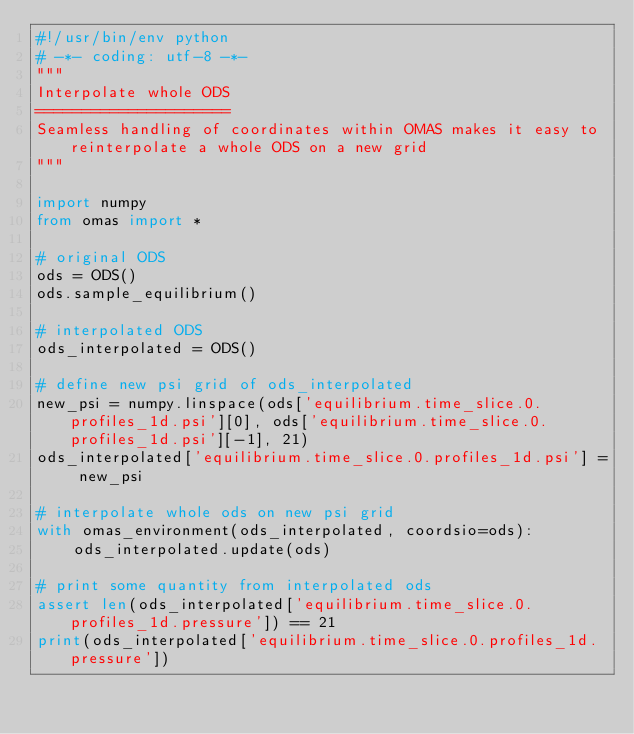Convert code to text. <code><loc_0><loc_0><loc_500><loc_500><_Python_>#!/usr/bin/env python
# -*- coding: utf-8 -*-
"""
Interpolate whole ODS
=====================
Seamless handling of coordinates within OMAS makes it easy to reinterpolate a whole ODS on a new grid
"""

import numpy
from omas import *

# original ODS
ods = ODS()
ods.sample_equilibrium()

# interpolated ODS
ods_interpolated = ODS()

# define new psi grid of ods_interpolated
new_psi = numpy.linspace(ods['equilibrium.time_slice.0.profiles_1d.psi'][0], ods['equilibrium.time_slice.0.profiles_1d.psi'][-1], 21)
ods_interpolated['equilibrium.time_slice.0.profiles_1d.psi'] = new_psi

# interpolate whole ods on new psi grid
with omas_environment(ods_interpolated, coordsio=ods):
    ods_interpolated.update(ods)

# print some quantity from interpolated ods
assert len(ods_interpolated['equilibrium.time_slice.0.profiles_1d.pressure']) == 21
print(ods_interpolated['equilibrium.time_slice.0.profiles_1d.pressure'])
</code> 